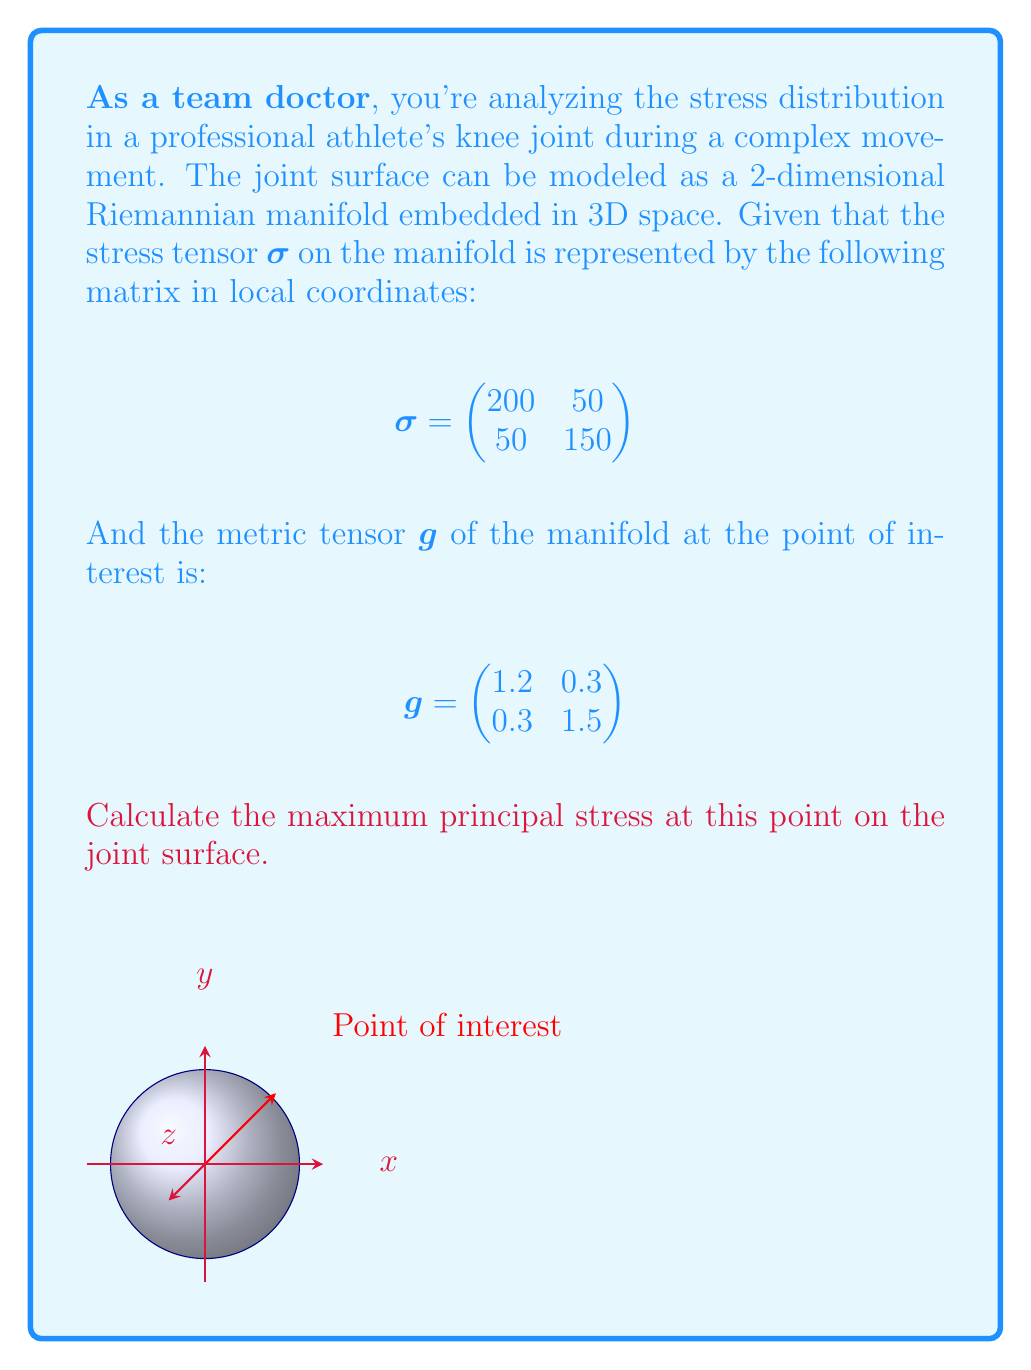Teach me how to tackle this problem. To find the maximum principal stress, we need to follow these steps:

1) First, we need to raise one index of the stress tensor using the metric tensor. This gives us the mixed tensor $\sigma^i_j$:

   $$\sigma^i_j = g^{ik}\sigma_{kj}$$

   Where $g^{ik}$ is the inverse of the metric tensor.

2) Calculate the inverse of the metric tensor:

   $$g^{-1} = \frac{1}{1.2 \cdot 1.5 - 0.3 \cdot 0.3} \begin{pmatrix}
   1.5 & -0.3 \\
   -0.3 & 1.2
   \end{pmatrix} = \begin{pmatrix}
   0.8889 & -0.1778 \\
   -0.1778 & 0.7111
   \end{pmatrix}$$

3) Now, calculate $\sigma^i_j$:

   $$\sigma^i_j = \begin{pmatrix}
   0.8889 & -0.1778 \\
   -0.1778 & 0.7111
   \end{pmatrix} \begin{pmatrix}
   200 & 50 \\
   50 & 150
   \end{pmatrix} = \begin{pmatrix}
   166.67 & 35.56 \\
   26.67 & 102.22
   \end{pmatrix}$$

4) The eigenvalues of this matrix will give us the principal stresses. The characteristic equation is:

   $$\det(\sigma^i_j - \lambda I) = 0$$

   $$(166.67 - \lambda)(102.22 - \lambda) - 35.56 \cdot 26.67 = 0$$

5) Solving this quadratic equation:

   $$\lambda^2 - 268.89\lambda + 16001.78 = 0$$

6) The solutions are:

   $$\lambda_1 = 184.31, \lambda_2 = 84.58$$

7) The maximum principal stress is the larger eigenvalue.
Answer: 184.31 